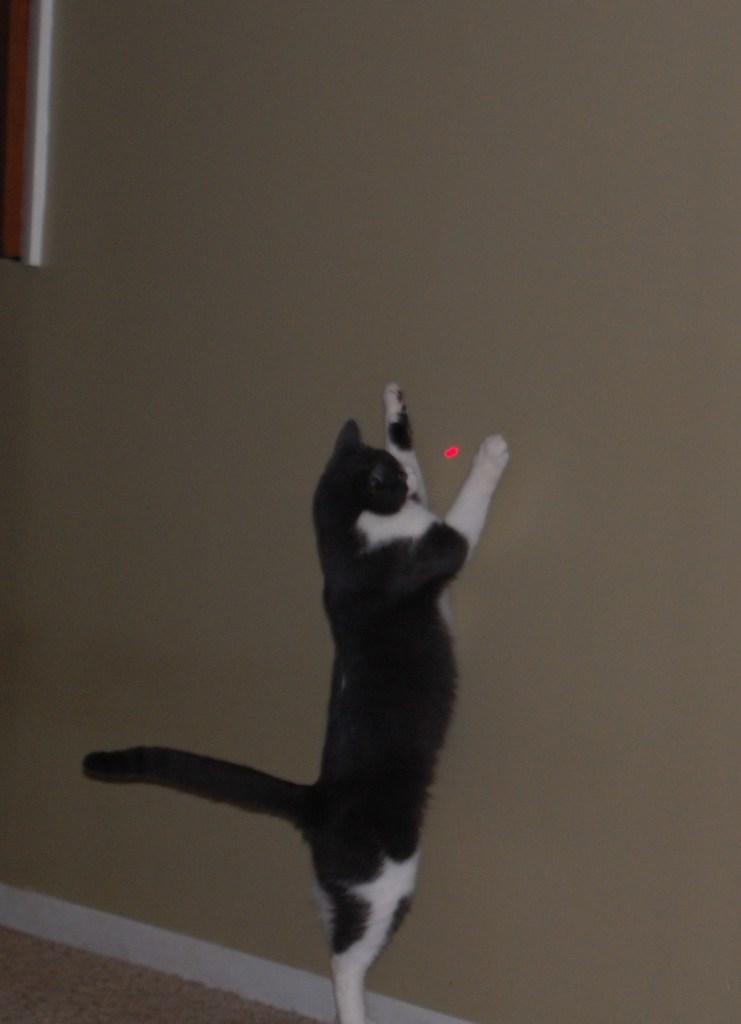What type of animal is in the image? There is a cat in the image. Where is the cat positioned in the image? The cat is standing on the floor. What is near the cat in the image? The cat is near a wall. What is on the wall in the image? There is an object on the wall and a laser light. What color is the curtain hanging in front of the wall in the image? There is no curtain present in the image. What is the aftermath of the cat's interaction with the laser light in the image? The image does not depict any interaction between the cat and the laser light, so there is no aftermath to describe. 